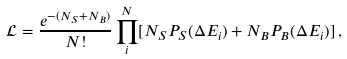Convert formula to latex. <formula><loc_0><loc_0><loc_500><loc_500>\mathcal { L } = \frac { e ^ { - ( N _ { S } + N _ { B } ) } } { N ! } \prod _ { i } ^ { N } [ N _ { S } P _ { S } ( \Delta E _ { i } ) + N _ { B } P _ { B } ( \Delta E _ { i } ) ] \, ,</formula> 